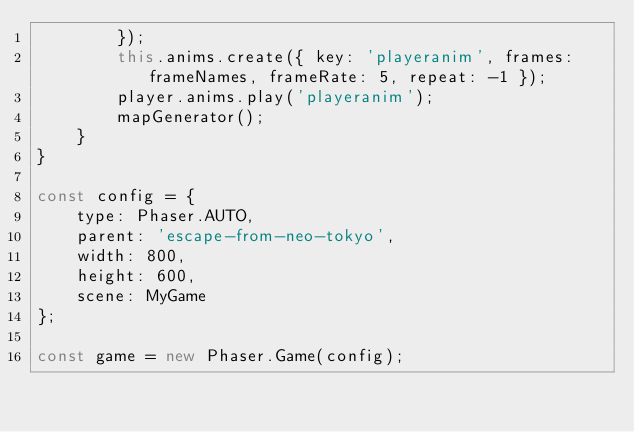Convert code to text. <code><loc_0><loc_0><loc_500><loc_500><_JavaScript_>        });
        this.anims.create({ key: 'playeranim', frames: frameNames, frameRate: 5, repeat: -1 });
        player.anims.play('playeranim');
        mapGenerator();
    }
}

const config = {
    type: Phaser.AUTO,
    parent: 'escape-from-neo-tokyo',
    width: 800,
    height: 600,
    scene: MyGame
};

const game = new Phaser.Game(config);
</code> 